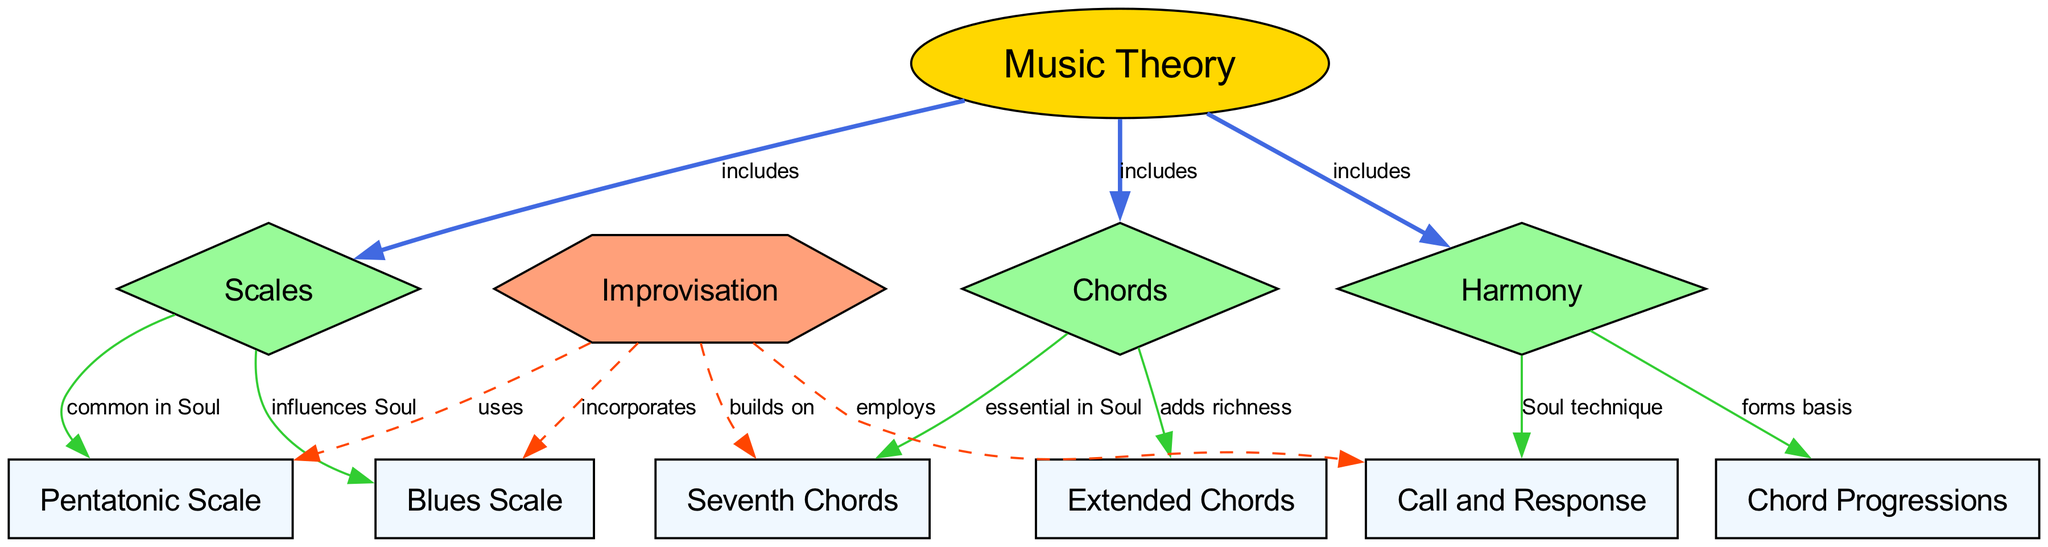What are the three main categories included in Music Theory? The diagram shows that Music Theory includes Scales, Chords, and Harmony, as indicated by the three edges labeled "includes" leading from Music Theory to these three nodes.
Answer: Scales, Chords, Harmony How many nodes are present in the diagram? By counting all the distinct node identifiers from the provided data, there are 11 nodes total in the diagram.
Answer: 11 What scale is common in Soul music? The diagram indicates that the Pentatonic Scale is noted as common in Soul, as shown by the edge leading from Scales to Pentatonic Scale labeled "common in Soul."
Answer: Pentatonic Scale Which type of chords is essential in Soul music? The edge connecting Chords to Seventh Chords in the diagram is labeled "essential in Soul," indicating that Seventh Chords are specifically highlighted as significant in that genre.
Answer: Seventh Chords What type of relationship exists between Improvisation and the Blues Scale? The diagram shows a dashed edge from Improvisation to Blues Scale labeled "incorporates," indicating that there is a relationship where improvisation includes elements of the Blues Scale.
Answer: incorporates What forms the basis of Harmony? According to the diagram, the edge labeled "forms basis" connects Harmony to Chord Progressions, which signifies that Chord Progressions serve as a foundational element of Harmony.
Answer: Chord Progressions How does Improvisation relate to Call and Response? The edge labeled "employs" connects Improvisation to Call and Response, suggesting that Improvisation employs this particular technique, highlighting its significance in practical musical applications.
Answer: employs What type of chord adds richness? The diagram identifies Extended Chords as adding richness, shown by the edge from Chords to Extended Chords labeled "adds richness."
Answer: Extended Chords Which scale influences Soul? The Blues Scale is indicated in the diagram as having an influence on Soul music, as noted by the edge from Scales to Blues Scale labeled "influences Soul."
Answer: Blues Scale 